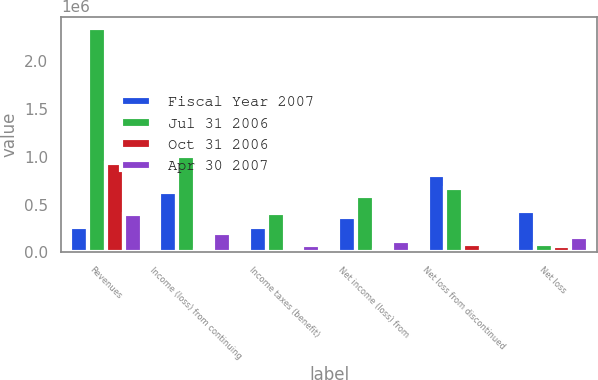Convert chart. <chart><loc_0><loc_0><loc_500><loc_500><stacked_bar_chart><ecel><fcel>Revenues<fcel>Income (loss) from continuing<fcel>Income taxes (benefit)<fcel>Net income (loss) from<fcel>Net loss from discontinued<fcel>Net loss<nl><fcel>Fiscal Year 2007<fcel>261461<fcel>635798<fcel>261461<fcel>374337<fcel>807990<fcel>433653<nl><fcel>Jul 31 2006<fcel>2.35124e+06<fcel>1.00627e+06<fcel>415037<fcel>591229<fcel>676793<fcel>85564<nl><fcel>Oct 31 2006<fcel>931179<fcel>22125<fcel>181<fcel>21944<fcel>82196<fcel>60252<nl><fcel>Apr 30 2007<fcel>396083<fcel>198619<fcel>77622<fcel>120997<fcel>35463<fcel>156460<nl></chart> 